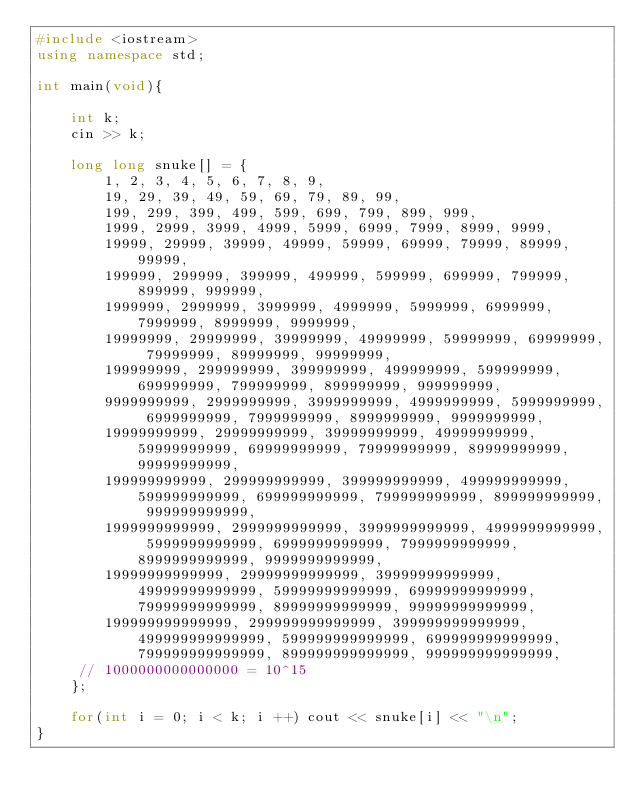<code> <loc_0><loc_0><loc_500><loc_500><_C++_>#include <iostream>
using namespace std;
 
int main(void){
    
    int k;
    cin >> k;
    
    long long snuke[] = {
        1, 2, 3, 4, 5, 6, 7, 8, 9,
        19, 29, 39, 49, 59, 69, 79, 89, 99,
        199, 299, 399, 499, 599, 699, 799, 899, 999,
        1999, 2999, 3999, 4999, 5999, 6999, 7999, 8999, 9999,
        19999, 29999, 39999, 49999, 59999, 69999, 79999, 89999, 99999,
        199999, 299999, 399999, 499999, 599999, 699999, 799999, 899999, 999999,
        1999999, 2999999, 3999999, 4999999, 5999999, 6999999, 7999999, 8999999, 9999999,
        19999999, 29999999, 39999999, 49999999, 59999999, 69999999, 79999999, 89999999, 99999999,
        199999999, 299999999, 399999999, 499999999, 599999999, 699999999, 799999999, 899999999, 999999999,
        9999999999, 2999999999, 3999999999, 4999999999, 5999999999, 6999999999, 7999999999, 8999999999, 9999999999,
        19999999999, 29999999999, 39999999999, 49999999999, 59999999999, 69999999999, 79999999999, 89999999999, 99999999999,
        199999999999, 299999999999, 399999999999, 499999999999, 599999999999, 699999999999, 799999999999, 899999999999, 999999999999,
        1999999999999, 2999999999999, 3999999999999, 4999999999999, 5999999999999, 6999999999999, 7999999999999, 8999999999999, 9999999999999,
        19999999999999, 29999999999999, 39999999999999, 49999999999999, 59999999999999, 69999999999999, 79999999999999, 89999999999999, 99999999999999,
        199999999999999, 299999999999999, 399999999999999, 499999999999999, 599999999999999, 699999999999999, 799999999999999, 899999999999999, 999999999999999,
     // 1000000000000000 = 10^15
    };
    
    for(int i = 0; i < k; i ++) cout << snuke[i] << "\n";
}</code> 